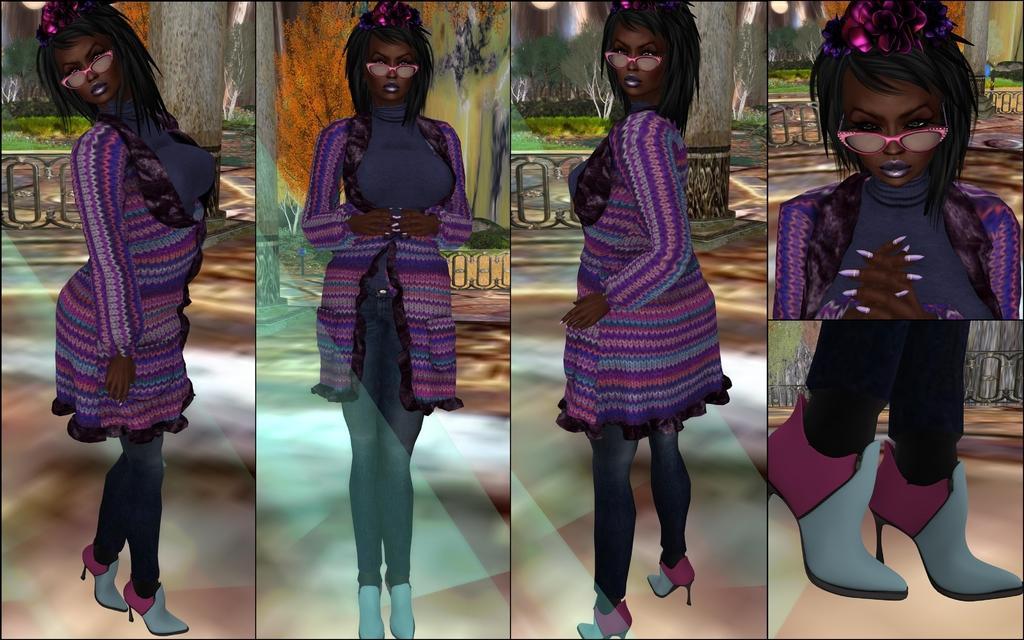Please provide a concise description of this image. This is collage picture,in these pictures we can see same woman. In the background we can see painting of plant and tree trunk. 